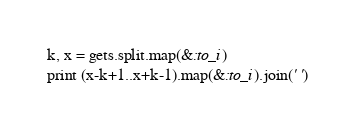<code> <loc_0><loc_0><loc_500><loc_500><_Ruby_>k, x = gets.split.map(&:to_i)
print (x-k+1..x+k-1).map(&:to_i).join(' ')</code> 